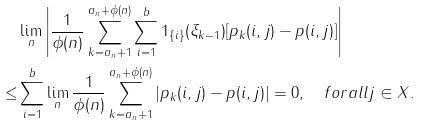Convert formula to latex. <formula><loc_0><loc_0><loc_500><loc_500>& \lim _ { n } \left | \frac { 1 } { \phi ( n ) } \sum _ { k = a _ { n } + 1 } ^ { a _ { n } + \phi ( n ) } \sum _ { i = 1 } ^ { b } 1 _ { \{ i \} } ( \xi _ { k - 1 } ) [ p _ { k } ( i , j ) - p ( i , j ) ] \right | \\ \leq & \sum _ { i = 1 } ^ { b } \lim _ { n } \frac { 1 } { \phi ( n ) } \sum _ { k = a _ { n } + 1 } ^ { a _ { n } + \phi ( n ) } | p _ { k } ( i , j ) - p ( i , j ) | = 0 , \quad f o r a l l j \in X .</formula> 